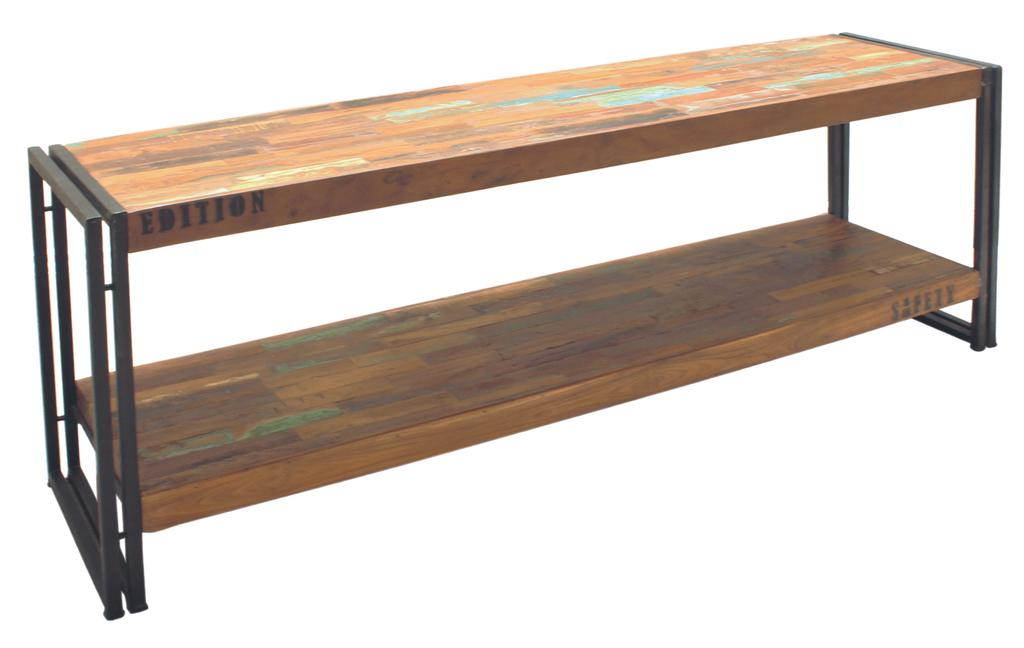<image>
Give a short and clear explanation of the subsequent image. A wooden shelving unit has the word Edition stenciled onto the side. 